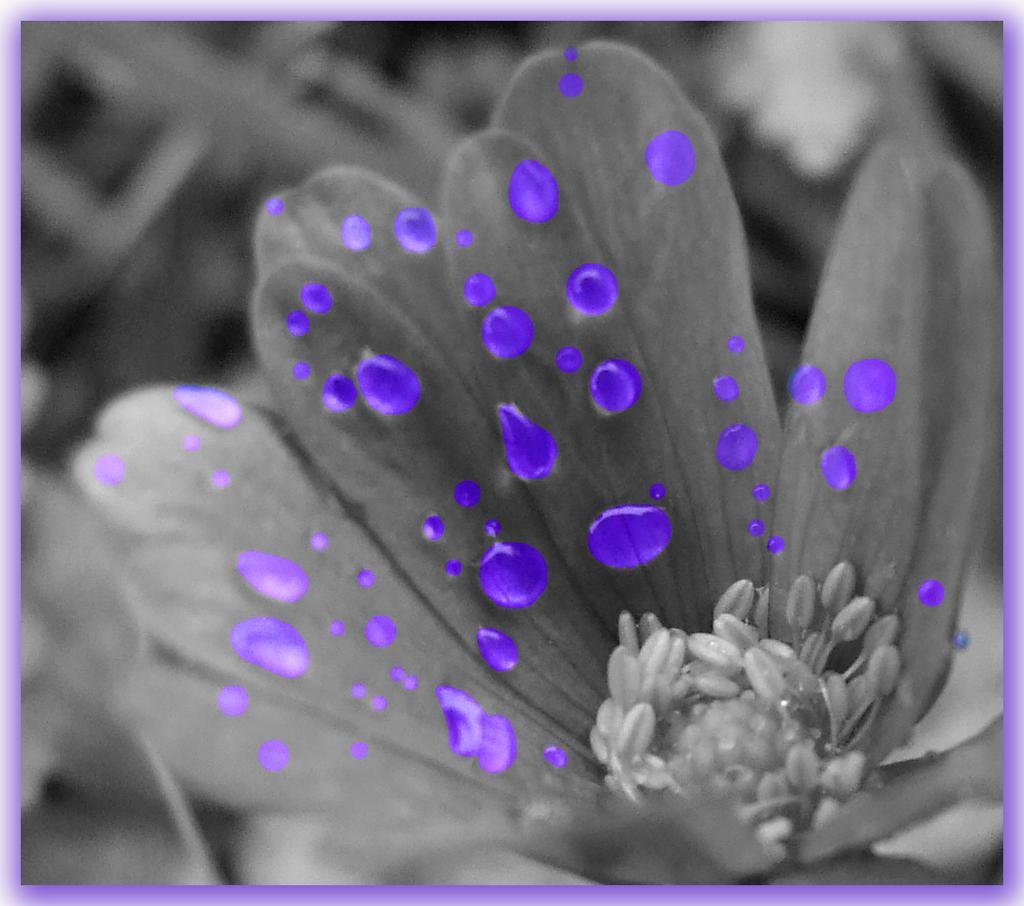How would you summarize this image in a sentence or two? This is edited image, in this image there is a black and white flower and on that there are blue water drops. 